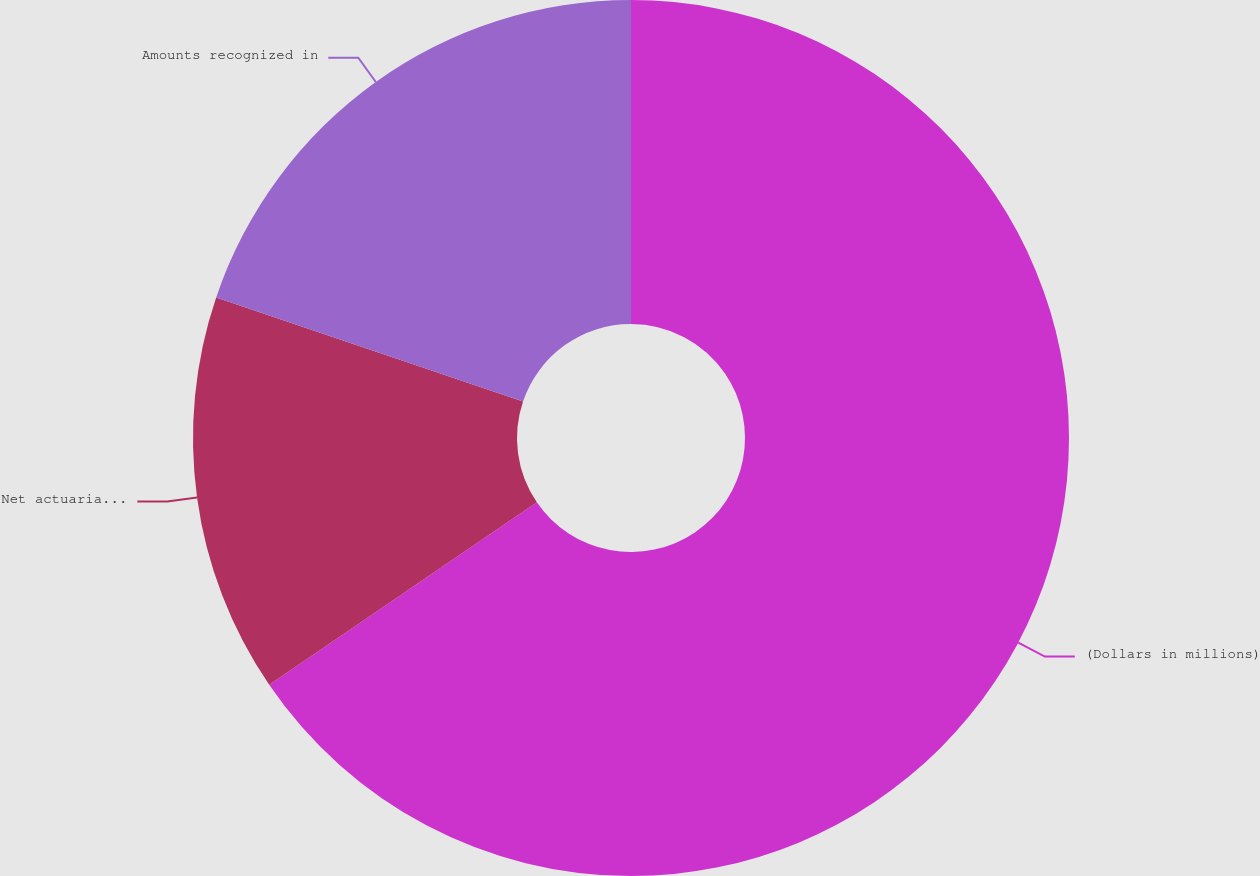<chart> <loc_0><loc_0><loc_500><loc_500><pie_chart><fcel>(Dollars in millions)<fcel>Net actuarial loss (gain)<fcel>Amounts recognized in<nl><fcel>65.47%<fcel>14.73%<fcel>19.8%<nl></chart> 